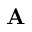Convert formula to latex. <formula><loc_0><loc_0><loc_500><loc_500>A</formula> 